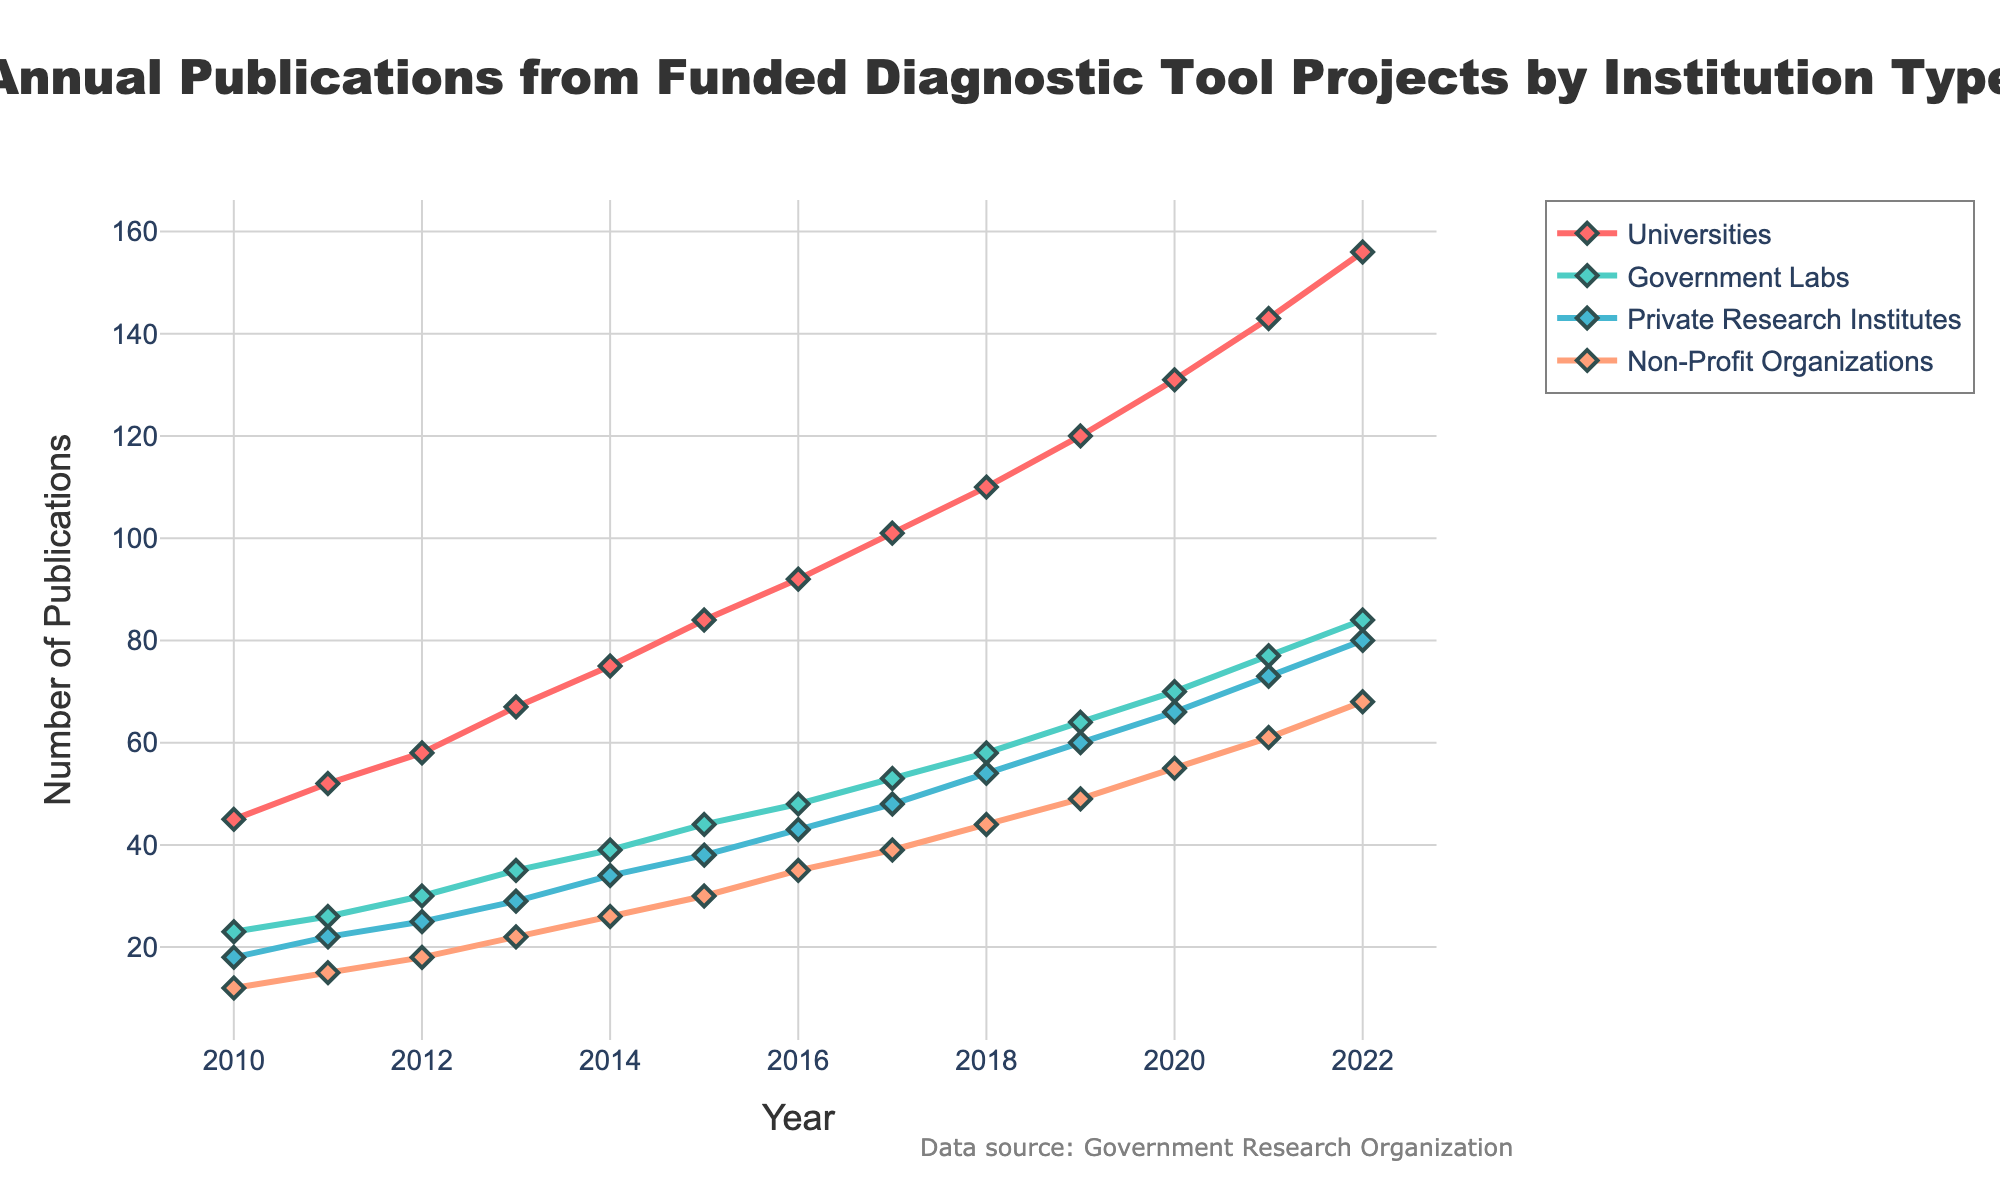Which institution type had the highest number of publications in 2010? The data points for each institution type in 2010 can be read directly. Universities had the highest value with 45 publications, compared to Government Labs (23), Private Research Institutes (18), and Non-Profit Organizations (12).
Answer: Universities How many total publications were made across all institutions in the year 2015? Sum the data points from the year 2015 for all institution types: 84 (Universities) + 44 (Government Labs) + 38 (Private Research Institutes) + 30 (Non-Profit Organizations). The total is 84 + 44 + 38 + 30 = 196.
Answer: 196 Which institution showed the largest increase in the number of publications from 2010 to 2022? Calculate the difference in the number of publications from 2010 to 2022 for each institution: Universities (156 - 45 = 111), Government Labs (84 - 23 = 61), Private Research Institutes (80 - 18 = 62), Non-Profit Organizations (68 - 12 = 56). The largest increase is 111 for Universities.
Answer: Universities In what year did Non-Profit Organizations surpass 40 publications annually? Identify the year in which the number of publications by Non-Profit Organizations first exceeded 40. This occurred in 2018 with 44 publications.
Answer: 2018 By how much did the number of publications by Government Labs exceed those by Private Research Institutes in 2020? Subtract the number of publications by Private Research Institutes from those by Government Labs in 2020: 70 (Government Labs) - 66 (Private Research Institutes) = 4.
Answer: 4 What is the average number of publications by Universities over the period 2010-2022? Add the number of publications by Universities for each year from 2010 to 2022 and divide by the number of years: (45 + 52 + 58 + 67 + 75 + 84 + 92 + 101 + 110 + 120 + 131 + 143 + 156) / 13. The sum is 1234, and the average is 1234 / 13 ≈ 94.92.
Answer: 94.92 Which color represents the trace for Private Research Institutes, and what was their publication count in 2015? The figure indicates that Private Research Institutes are represented by a blue-colored line, and the publication count for this group in 2015 is 38.
Answer: Blue, 38 What were the publication counts for Universities and Government Labs in 2013, and how do they compare? The publication counts for 2013 are 67 for Universities and 35 for Government Labs. Universities had 67 - 35 = 32 more publications than Government Labs in this year.
Answer: Universities had 32 more How many more publications did Universities have compared to Non-Profit Organizations in 2022? Subtract the number of publications by Non-Profit Organizations from those by Universities in 2022: 156 (Universities) - 68 (Non-Profit Organizations) = 88.
Answer: 88 What trend can be observed in the number of publications by Non-Profit Organizations from 2010 to 2022? The number of publications by Non-Profit Organizations shows a consistent upward trend from 12 in 2010 to 68 in 2022, indicating steady growth over the years.
Answer: Steady growth 